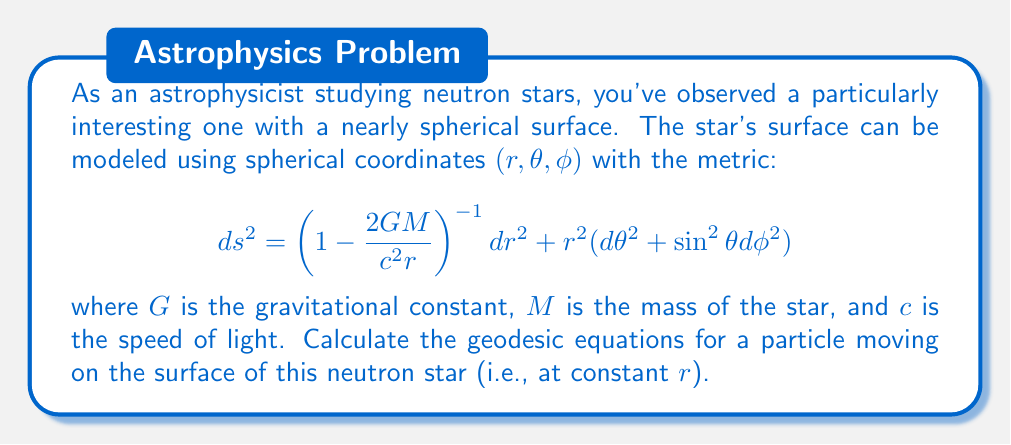Could you help me with this problem? To solve this problem, we'll follow these steps:

1) First, we need to identify the metric components. From the given metric:
   $$g_{rr} = \left(1 - \frac{2GM}{c^2r}\right)^{-1}, \quad g_{\theta\theta} = r^2, \quad g_{\phi\phi} = r^2\sin^2\theta$$

2) Since we're considering motion on the surface, $r$ is constant. So we only need to consider the $\theta$ and $\phi$ components of the geodesic equation.

3) The geodesic equation in general form is:
   $$\frac{d^2x^\mu}{ds^2} + \Gamma^\mu_{\alpha\beta}\frac{dx^\alpha}{ds}\frac{dx^\beta}{ds} = 0$$

4) We need to calculate the Christoffel symbols $\Gamma^\mu_{\alpha\beta}$. For a sphere (which our surface approximates), the non-zero symbols are:
   $$\Gamma^\theta_{\phi\phi} = -\sin\theta\cos\theta, \quad \Gamma^\phi_{\theta\phi} = \Gamma^\phi_{\phi\theta} = \cot\theta$$

5) Now, we can write out the geodesic equations:

   For $\theta$:
   $$\frac{d^2\theta}{ds^2} - \sin\theta\cos\theta\left(\frac{d\phi}{ds}\right)^2 = 0$$

   For $\phi$:
   $$\frac{d^2\phi}{ds^2} + 2\cot\theta\frac{d\theta}{ds}\frac{d\phi}{ds} = 0$$

6) These equations describe the motion of a particle on the surface of the neutron star, taking into account the curvature of spacetime near the star.
Answer: $$\frac{d^2\theta}{ds^2} - \sin\theta\cos\theta\left(\frac{d\phi}{ds}\right)^2 = 0$$
$$\frac{d^2\phi}{ds^2} + 2\cot\theta\frac{d\theta}{ds}\frac{d\phi}{ds} = 0$$ 